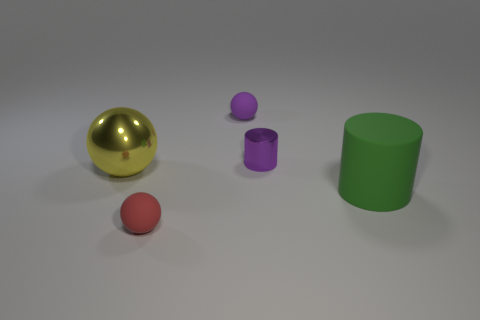Is there a rubber object of the same color as the small metal object?
Provide a short and direct response. Yes. There is a tiny matte sphere behind the small metal thing; is it the same color as the small metallic cylinder?
Keep it short and to the point. Yes. Is the number of red matte balls to the left of the purple cylinder greater than the number of big matte things in front of the red matte sphere?
Provide a short and direct response. Yes. Are there more large green things than rubber objects?
Provide a succinct answer. No. There is a matte object that is both behind the small red object and to the left of the purple metallic cylinder; what size is it?
Make the answer very short. Small. What shape is the large yellow object?
Make the answer very short. Sphere. Are there more shiny balls to the left of the small purple cylinder than small brown metal blocks?
Ensure brevity in your answer.  Yes. There is a large shiny object that is in front of the small rubber thing that is right of the matte object that is in front of the large cylinder; what shape is it?
Give a very brief answer. Sphere. There is a matte sphere that is on the left side of the purple rubber sphere; does it have the same size as the small cylinder?
Provide a short and direct response. Yes. The object that is both to the left of the purple metallic cylinder and behind the large yellow object has what shape?
Provide a short and direct response. Sphere. 